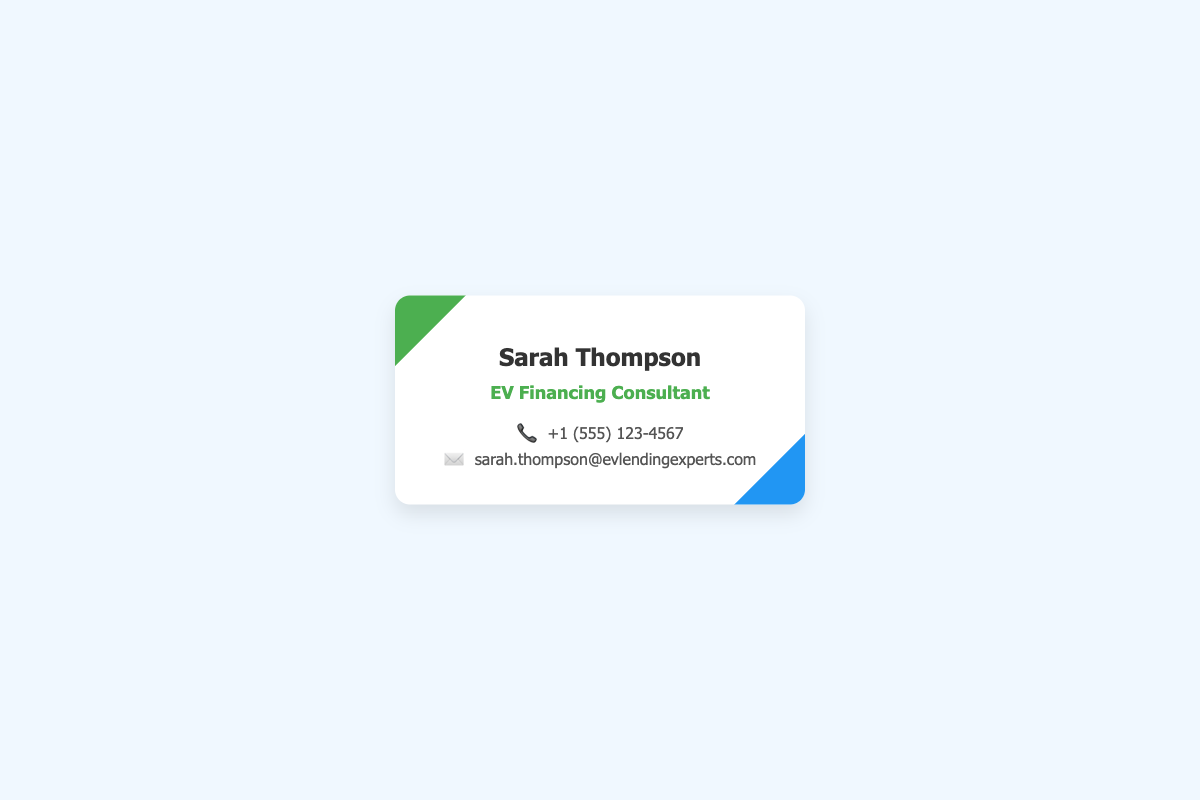what is the name of the consultant? The name of the consultant is displayed prominently at the top of the card.
Answer: Sarah Thompson what is Sarah Thompson's position? The position of Sarah Thompson is indicated below her name on the card.
Answer: EV Financing Consultant what is the phone number listed? The phone number is provided in the contact information section of the card.
Answer: +1 (555) 123-4567 what email address is provided? The email address can be found in the contact information section following the phone number.
Answer: sarah.thompson@evlendingexperts.com what color is the background of the business card? The background color of the card is described in the styling of the document.
Answer: white how many distinct colors are used in the card design? The card features several colors, including those used for the text and design elements.
Answer: three what is the shape of the business card? The card's visual design indicates its rounded edges and overall structure.
Answer: rectangular what is the primary service offered by Sarah Thompson? The service is indicated by her title listed under her name on the card.
Answer: EV financing what is the significance of the icons next to the contact information? The icons serve as visual representations of the contact methods listed.
Answer: they indicate phone and email 